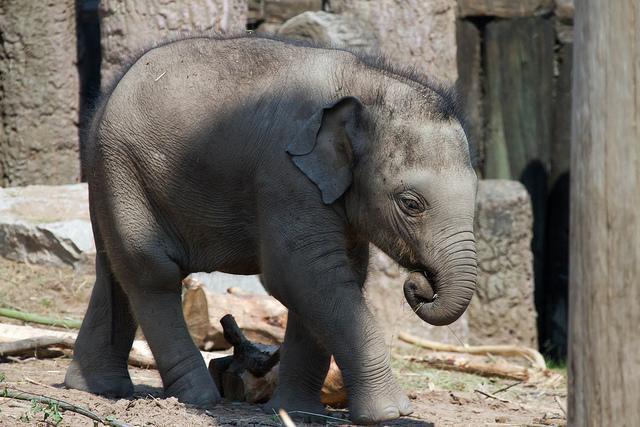How many eyes are there?
Give a very brief answer. 1. 